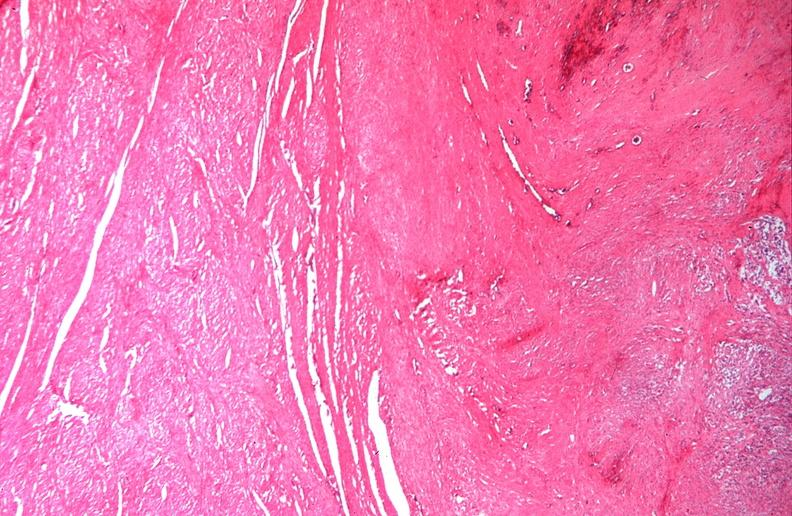s female reproductive present?
Answer the question using a single word or phrase. Yes 